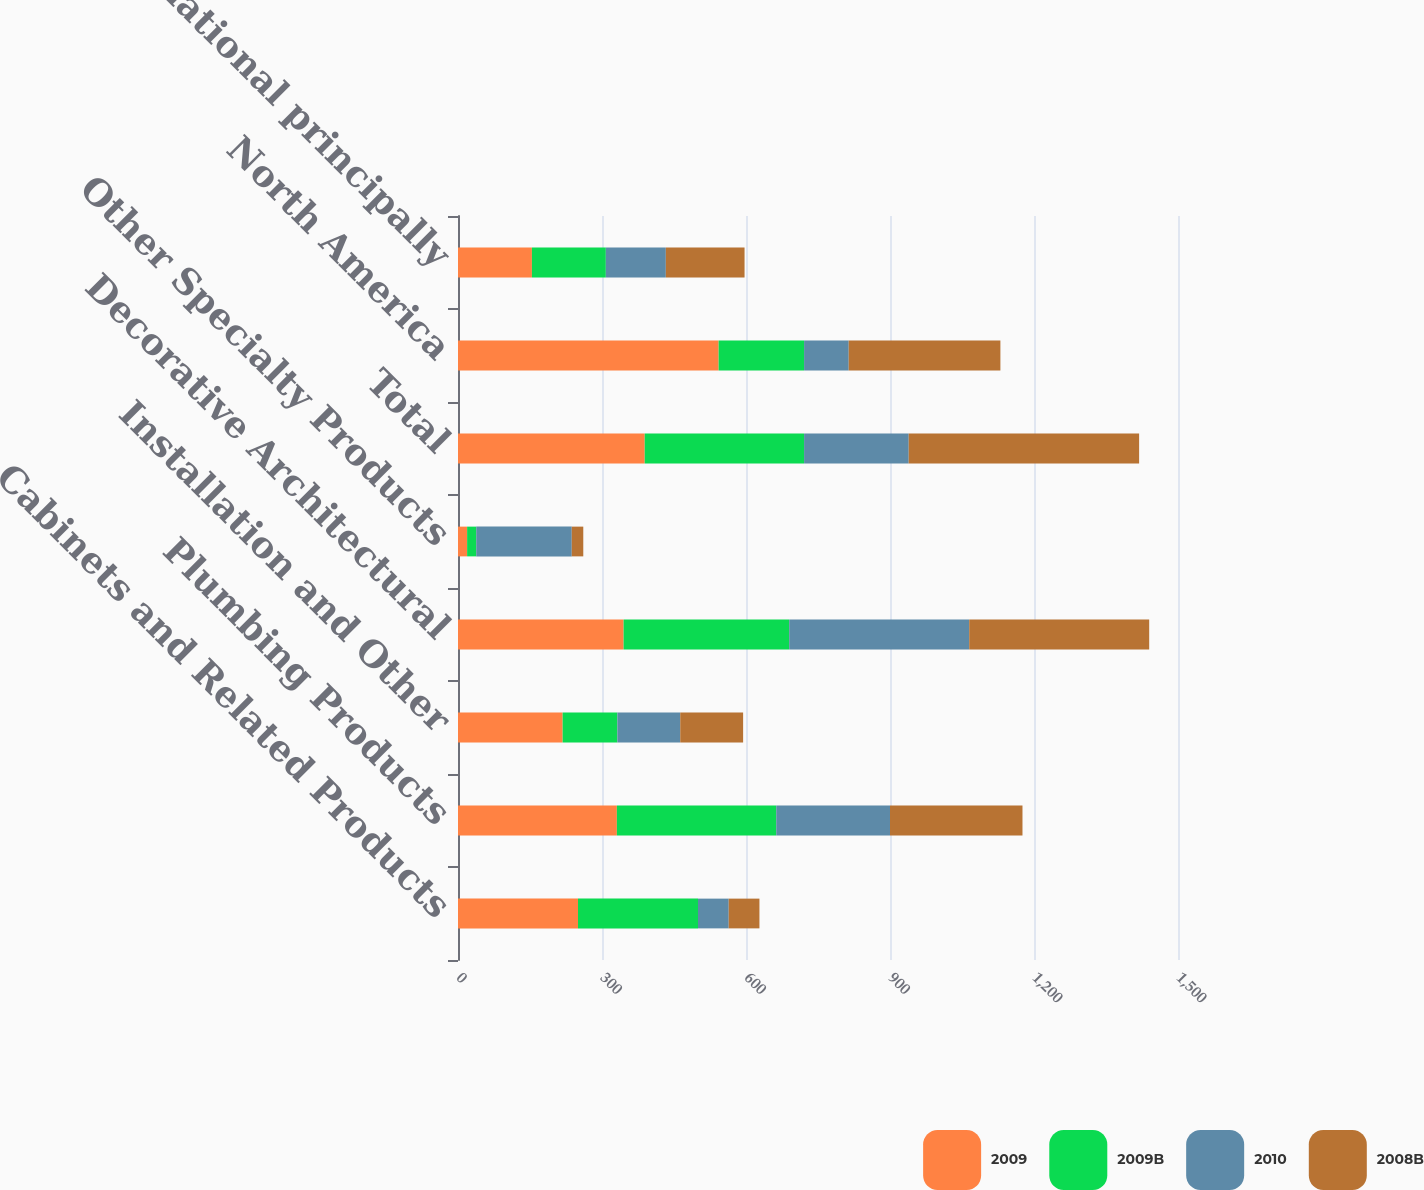<chart> <loc_0><loc_0><loc_500><loc_500><stacked_bar_chart><ecel><fcel>Cabinets and Related Products<fcel>Plumbing Products<fcel>Installation and Other<fcel>Decorative Architectural<fcel>Other Specialty Products<fcel>Total<fcel>North America<fcel>International principally<nl><fcel>2009<fcel>250<fcel>331<fcel>218<fcel>345<fcel>19<fcel>389<fcel>543<fcel>154<nl><fcel>2009B<fcel>250<fcel>332<fcel>114<fcel>345<fcel>19<fcel>332<fcel>178<fcel>154<nl><fcel>2010<fcel>64<fcel>237<fcel>131<fcel>375<fcel>199<fcel>218<fcel>93<fcel>125<nl><fcel>2008B<fcel>64<fcel>276<fcel>131<fcel>375<fcel>24<fcel>480<fcel>316<fcel>164<nl></chart> 